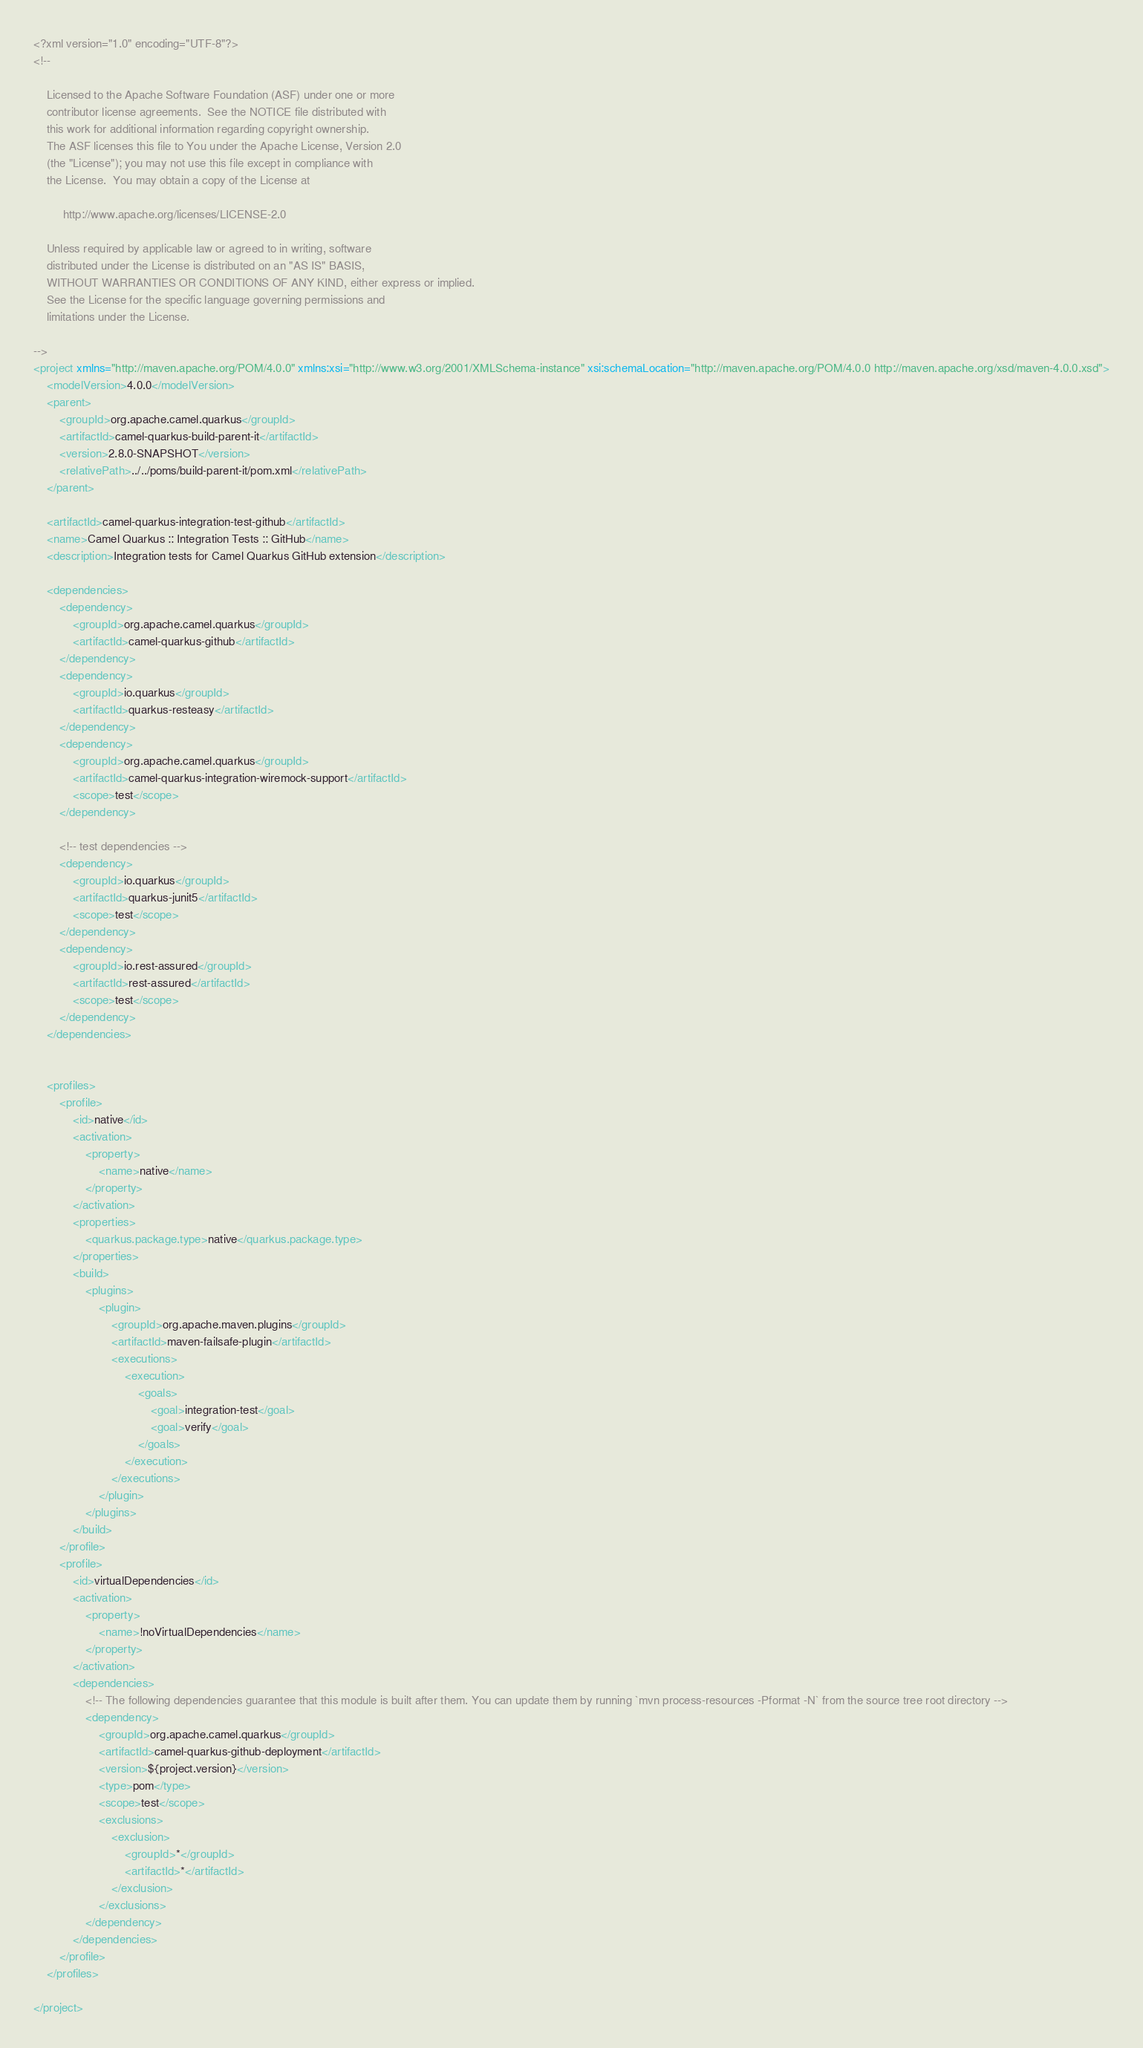<code> <loc_0><loc_0><loc_500><loc_500><_XML_><?xml version="1.0" encoding="UTF-8"?>
<!--

    Licensed to the Apache Software Foundation (ASF) under one or more
    contributor license agreements.  See the NOTICE file distributed with
    this work for additional information regarding copyright ownership.
    The ASF licenses this file to You under the Apache License, Version 2.0
    (the "License"); you may not use this file except in compliance with
    the License.  You may obtain a copy of the License at

         http://www.apache.org/licenses/LICENSE-2.0

    Unless required by applicable law or agreed to in writing, software
    distributed under the License is distributed on an "AS IS" BASIS,
    WITHOUT WARRANTIES OR CONDITIONS OF ANY KIND, either express or implied.
    See the License for the specific language governing permissions and
    limitations under the License.

-->
<project xmlns="http://maven.apache.org/POM/4.0.0" xmlns:xsi="http://www.w3.org/2001/XMLSchema-instance" xsi:schemaLocation="http://maven.apache.org/POM/4.0.0 http://maven.apache.org/xsd/maven-4.0.0.xsd">
    <modelVersion>4.0.0</modelVersion>
    <parent>
        <groupId>org.apache.camel.quarkus</groupId>
        <artifactId>camel-quarkus-build-parent-it</artifactId>
        <version>2.8.0-SNAPSHOT</version>
        <relativePath>../../poms/build-parent-it/pom.xml</relativePath>
    </parent>

    <artifactId>camel-quarkus-integration-test-github</artifactId>
    <name>Camel Quarkus :: Integration Tests :: GitHub</name>
    <description>Integration tests for Camel Quarkus GitHub extension</description>

    <dependencies>
        <dependency>
            <groupId>org.apache.camel.quarkus</groupId>
            <artifactId>camel-quarkus-github</artifactId>
        </dependency>
        <dependency>
            <groupId>io.quarkus</groupId>
            <artifactId>quarkus-resteasy</artifactId>
        </dependency>
        <dependency>
            <groupId>org.apache.camel.quarkus</groupId>
            <artifactId>camel-quarkus-integration-wiremock-support</artifactId>
            <scope>test</scope>
        </dependency>

        <!-- test dependencies -->
        <dependency>
            <groupId>io.quarkus</groupId>
            <artifactId>quarkus-junit5</artifactId>
            <scope>test</scope>
        </dependency>
        <dependency>
            <groupId>io.rest-assured</groupId>
            <artifactId>rest-assured</artifactId>
            <scope>test</scope>
        </dependency>
    </dependencies>


    <profiles>
        <profile>
            <id>native</id>
            <activation>
                <property>
                    <name>native</name>
                </property>
            </activation>
            <properties>
                <quarkus.package.type>native</quarkus.package.type>
            </properties>
            <build>
                <plugins>
                    <plugin>
                        <groupId>org.apache.maven.plugins</groupId>
                        <artifactId>maven-failsafe-plugin</artifactId>
                        <executions>
                            <execution>
                                <goals>
                                    <goal>integration-test</goal>
                                    <goal>verify</goal>
                                </goals>
                            </execution>
                        </executions>
                    </plugin>
                </plugins>
            </build>
        </profile>
        <profile>
            <id>virtualDependencies</id>
            <activation>
                <property>
                    <name>!noVirtualDependencies</name>
                </property>
            </activation>
            <dependencies>
                <!-- The following dependencies guarantee that this module is built after them. You can update them by running `mvn process-resources -Pformat -N` from the source tree root directory -->
                <dependency>
                    <groupId>org.apache.camel.quarkus</groupId>
                    <artifactId>camel-quarkus-github-deployment</artifactId>
                    <version>${project.version}</version>
                    <type>pom</type>
                    <scope>test</scope>
                    <exclusions>
                        <exclusion>
                            <groupId>*</groupId>
                            <artifactId>*</artifactId>
                        </exclusion>
                    </exclusions>
                </dependency>
            </dependencies>
        </profile>
    </profiles>

</project>
</code> 